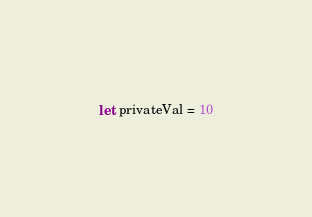<code> <loc_0><loc_0><loc_500><loc_500><_OCaml_>let privateVal = 10
</code> 